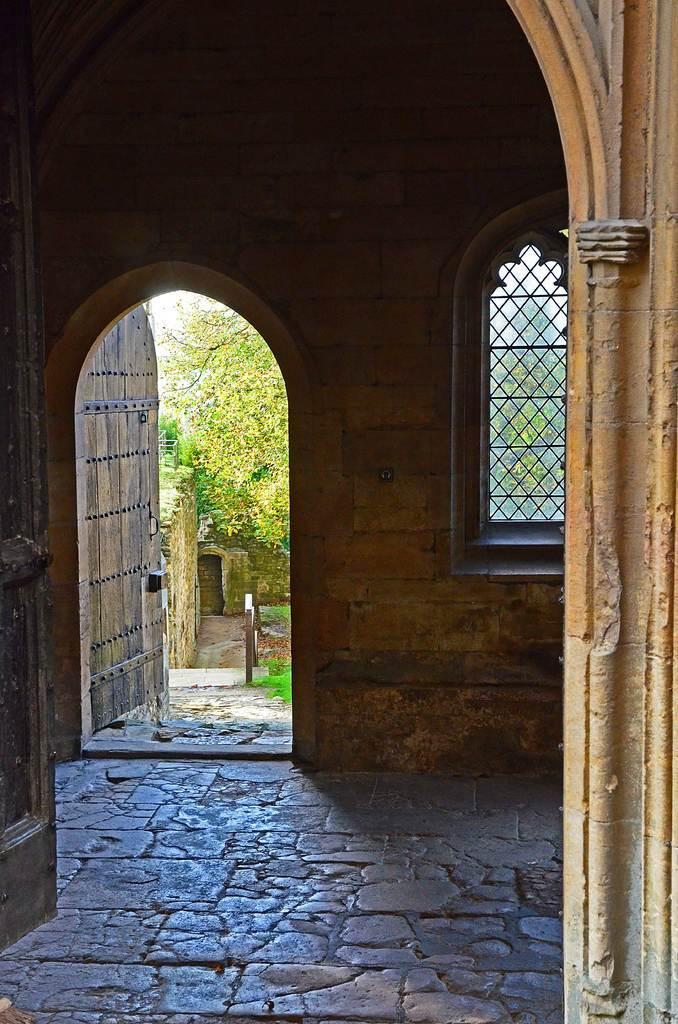Describe this image in one or two sentences. In this picture we can see an inside view of a building and in the background we can see trees. 